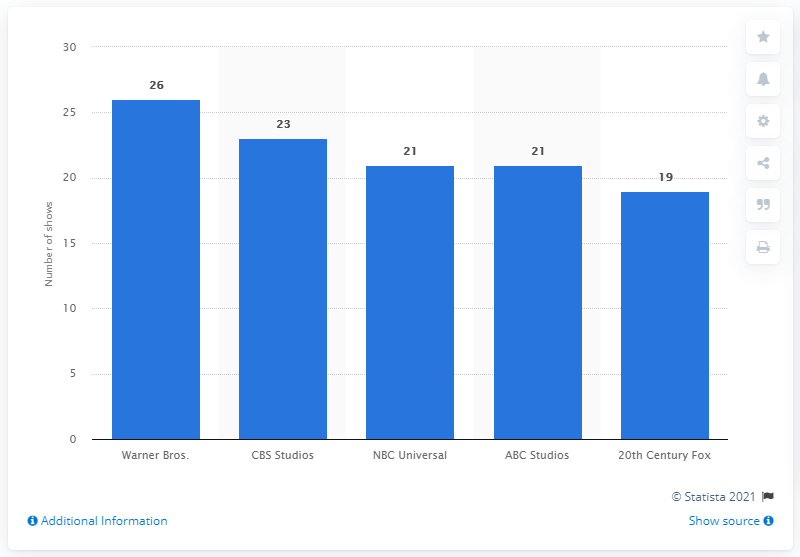Mention a couple of crucial points in this snapshot. In the 2014-15 season, a total of 21 scripted shows were in production. 